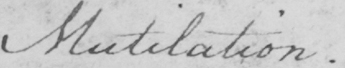Can you read and transcribe this handwriting? Mutilation. 